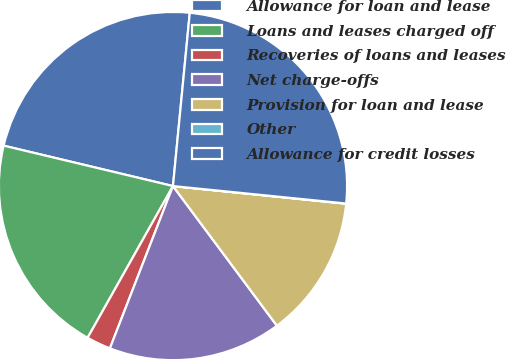Convert chart. <chart><loc_0><loc_0><loc_500><loc_500><pie_chart><fcel>Allowance for loan and lease<fcel>Loans and leases charged off<fcel>Recoveries of loans and leases<fcel>Net charge-offs<fcel>Provision for loan and lease<fcel>Other<fcel>Allowance for credit losses<nl><fcel>22.81%<fcel>20.57%<fcel>2.26%<fcel>16.08%<fcel>13.2%<fcel>0.02%<fcel>25.06%<nl></chart> 